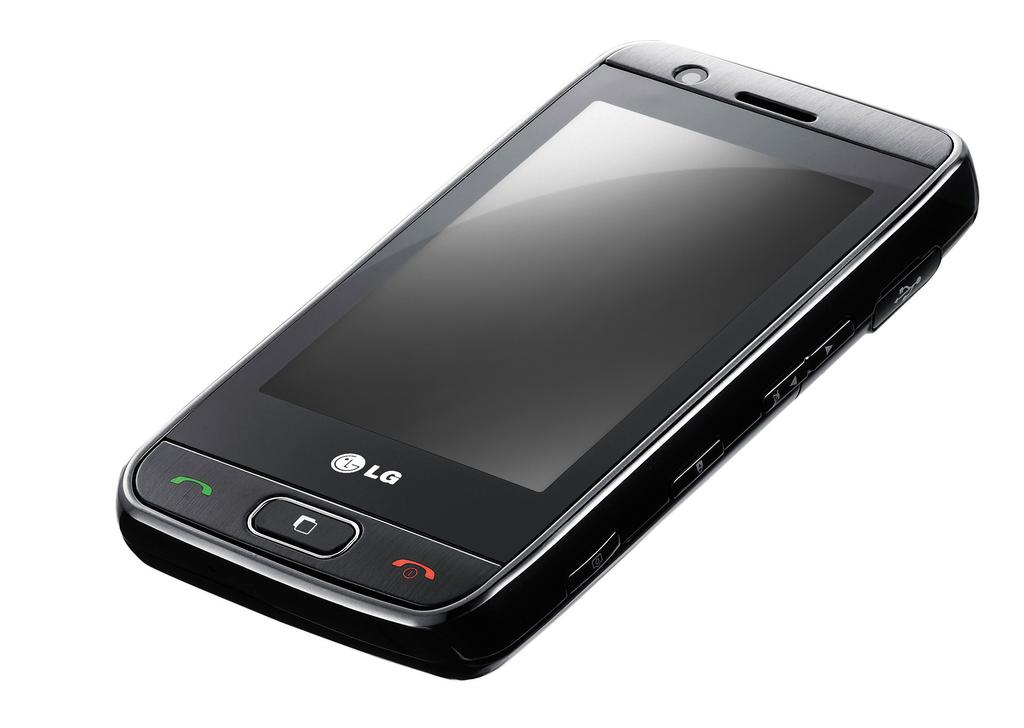<image>
Write a terse but informative summary of the picture. An LG electronic device turned faceup and turned off. 